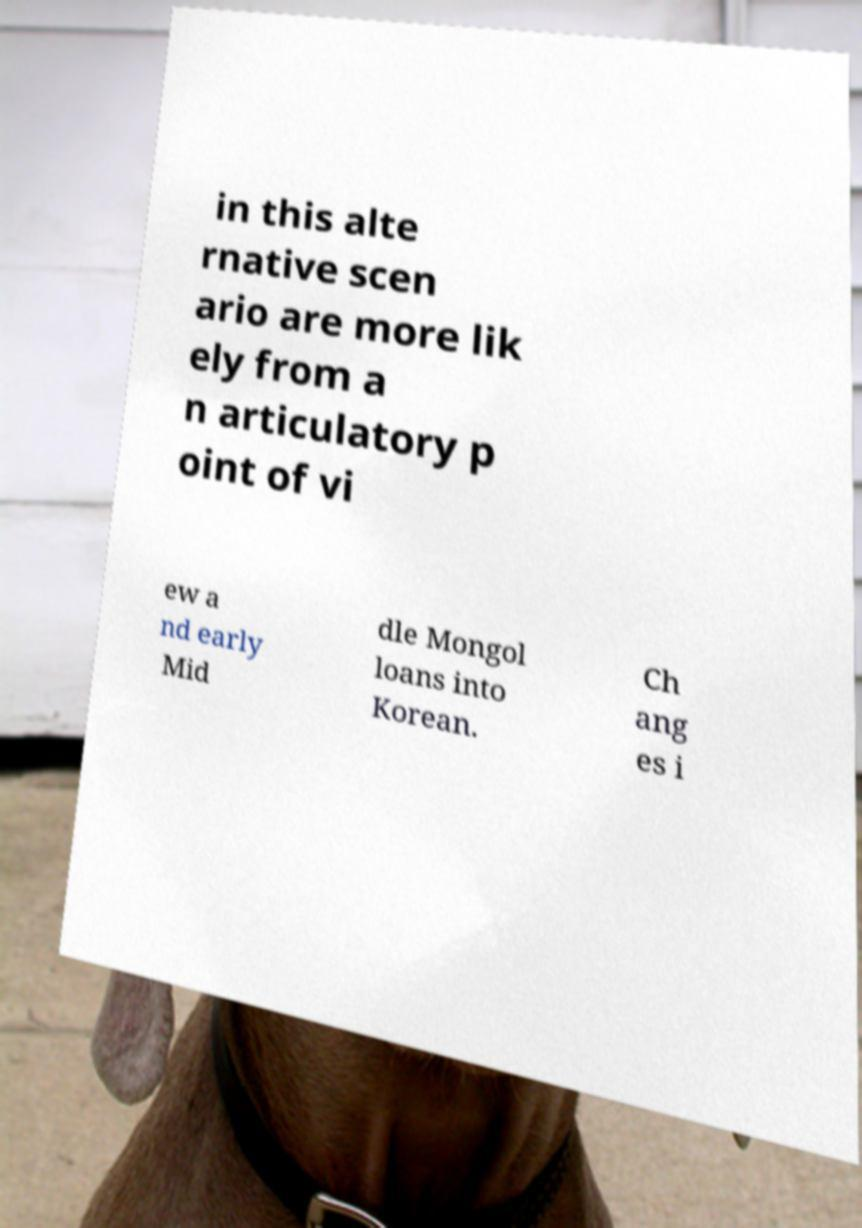There's text embedded in this image that I need extracted. Can you transcribe it verbatim? in this alte rnative scen ario are more lik ely from a n articulatory p oint of vi ew a nd early Mid dle Mongol loans into Korean. Ch ang es i 